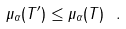Convert formula to latex. <formula><loc_0><loc_0><loc_500><loc_500>\mu _ { \alpha } ( T ^ { \prime } ) \leq \mu _ { \alpha } ( T ) \ .</formula> 